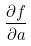<formula> <loc_0><loc_0><loc_500><loc_500>\frac { \partial f } { \partial a }</formula> 